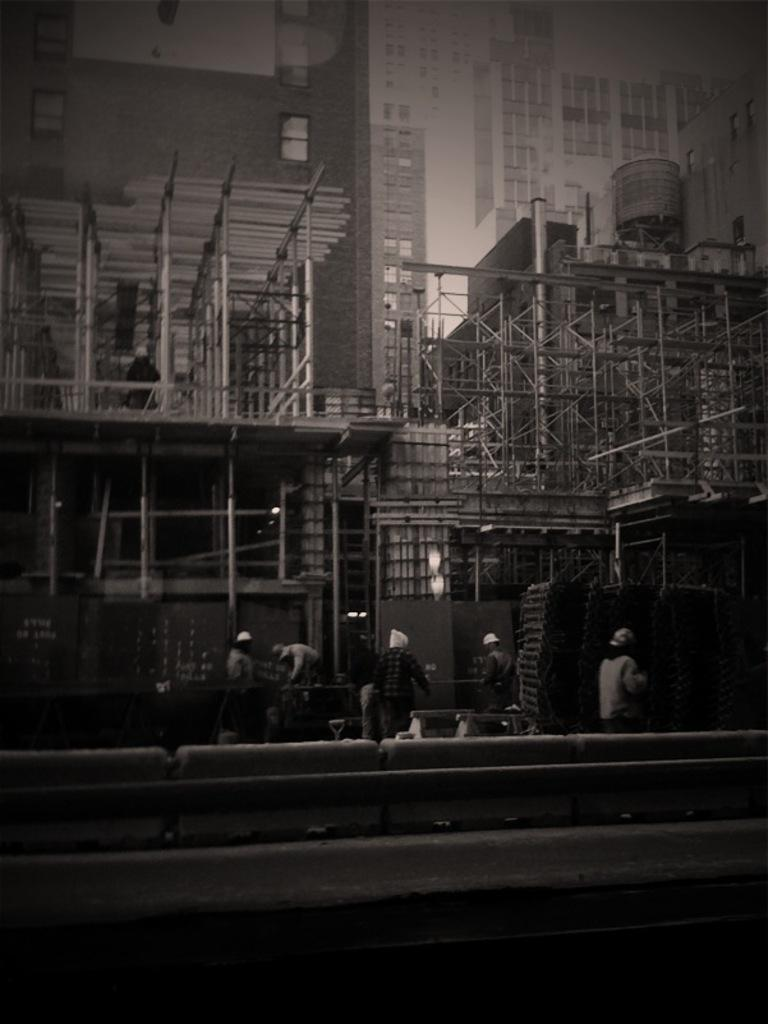What type of structures can be seen in the image? There are buildings in the image. What is located in front of the buildings? There are metal rods in front of the buildings. Can you describe the people visible in the image? There are people visible in the image. What type of illumination is present in the image? There are lights in the image. What architectural features can be seen on the buildings? There are windows in the image. What separates the lanes of traffic in the image? There is a road divider in the image. What type of ornament is hanging from the road divider in the image? There is no ornament hanging from the road divider in the image. In which direction are the buildings facing in the image? The image does not provide information about the direction the buildings are facing. Is there any oil visible in the image? There is no oil present in the image. 